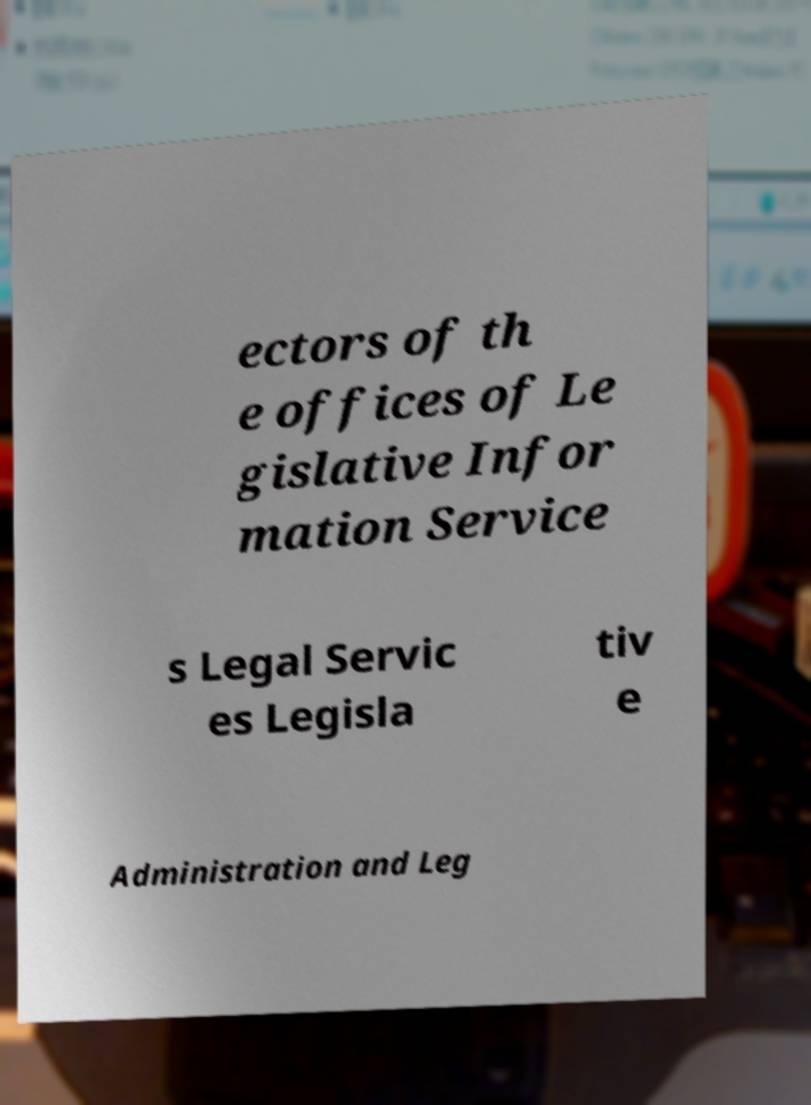Can you read and provide the text displayed in the image?This photo seems to have some interesting text. Can you extract and type it out for me? ectors of th e offices of Le gislative Infor mation Service s Legal Servic es Legisla tiv e Administration and Leg 